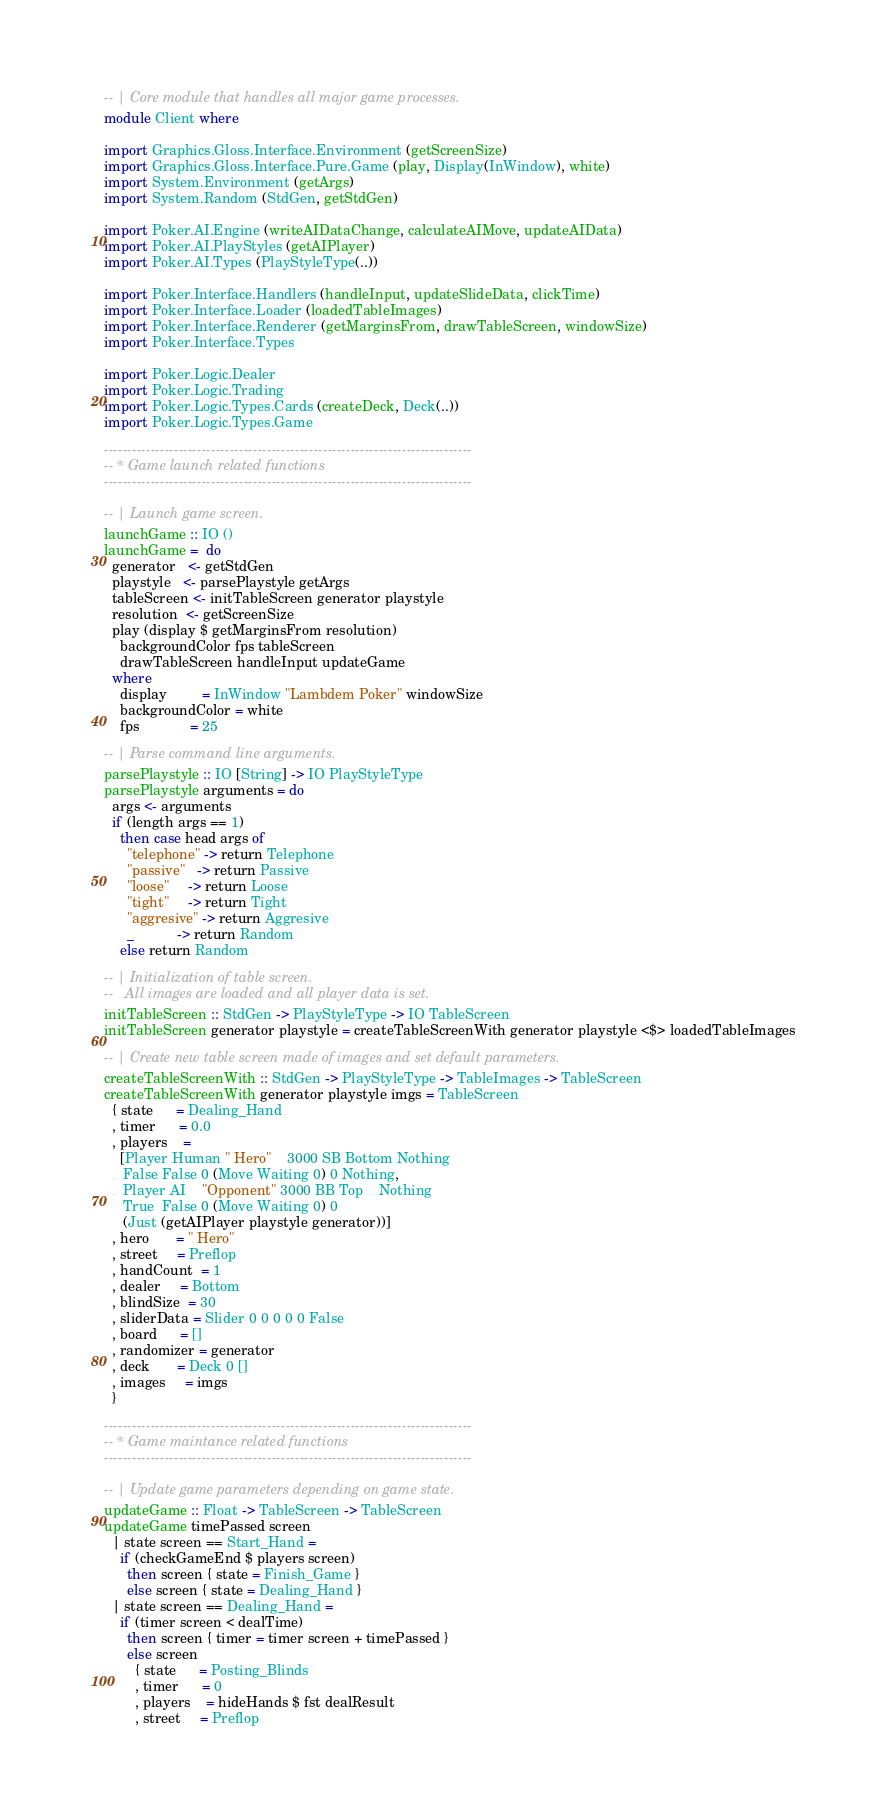Convert code to text. <code><loc_0><loc_0><loc_500><loc_500><_Haskell_>-- | Core module that handles all major game processes.
module Client where

import Graphics.Gloss.Interface.Environment (getScreenSize)
import Graphics.Gloss.Interface.Pure.Game (play, Display(InWindow), white)
import System.Environment (getArgs)
import System.Random (StdGen, getStdGen)

import Poker.AI.Engine (writeAIDataChange, calculateAIMove, updateAIData)
import Poker.AI.PlayStyles (getAIPlayer)
import Poker.AI.Types (PlayStyleType(..))

import Poker.Interface.Handlers (handleInput, updateSlideData, clickTime)
import Poker.Interface.Loader (loadedTableImages)
import Poker.Interface.Renderer (getMarginsFrom, drawTableScreen, windowSize)
import Poker.Interface.Types

import Poker.Logic.Dealer
import Poker.Logic.Trading
import Poker.Logic.Types.Cards (createDeck, Deck(..))
import Poker.Logic.Types.Game

-------------------------------------------------------------------------------
-- * Game launch related functions
-------------------------------------------------------------------------------

-- | Launch game screen.
launchGame :: IO ()
launchGame =  do
  generator   <- getStdGen
  playstyle   <- parsePlaystyle getArgs
  tableScreen <- initTableScreen generator playstyle
  resolution  <- getScreenSize
  play (display $ getMarginsFrom resolution)
    backgroundColor fps tableScreen
    drawTableScreen handleInput updateGame
  where
    display         = InWindow "Lambdem Poker" windowSize
    backgroundColor = white
    fps             = 25

-- | Parse command line arguments.
parsePlaystyle :: IO [String] -> IO PlayStyleType
parsePlaystyle arguments = do
  args <- arguments
  if (length args == 1)
    then case head args of
      "telephone" -> return Telephone
      "passive"   -> return Passive
      "loose"     -> return Loose
      "tight"     -> return Tight
      "aggresive" -> return Aggresive
      _           -> return Random
    else return Random

-- | Initialization of table screen.
--   All images are loaded and all player data is set.
initTableScreen :: StdGen -> PlayStyleType -> IO TableScreen
initTableScreen generator playstyle = createTableScreenWith generator playstyle <$> loadedTableImages

-- | Create new table screen made of images and set default parameters.
createTableScreenWith :: StdGen -> PlayStyleType -> TableImages -> TableScreen
createTableScreenWith generator playstyle imgs = TableScreen
  { state      = Dealing_Hand
  , timer      = 0.0
  , players    =
    [Player Human " Hero"    3000 SB Bottom Nothing
     False False 0 (Move Waiting 0) 0 Nothing,
     Player AI    "Opponent" 3000 BB Top    Nothing
     True  False 0 (Move Waiting 0) 0
     (Just (getAIPlayer playstyle generator))]
  , hero       = " Hero"
  , street     = Preflop
  , handCount  = 1
  , dealer     = Bottom
  , blindSize  = 30
  , sliderData = Slider 0 0 0 0 0 False
  , board      = []
  , randomizer = generator
  , deck       = Deck 0 []
  , images     = imgs
  }

-------------------------------------------------------------------------------
-- * Game maintance related functions
-------------------------------------------------------------------------------

-- | Update game parameters depending on game state.
updateGame :: Float -> TableScreen -> TableScreen
updateGame timePassed screen
  | state screen == Start_Hand =
    if (checkGameEnd $ players screen)
      then screen { state = Finish_Game }
      else screen { state = Dealing_Hand }
  | state screen == Dealing_Hand =
    if (timer screen < dealTime)
      then screen { timer = timer screen + timePassed }
      else screen 
        { state      = Posting_Blinds
        , timer      = 0
        , players    = hideHands $ fst dealResult
        , street     = Preflop</code> 